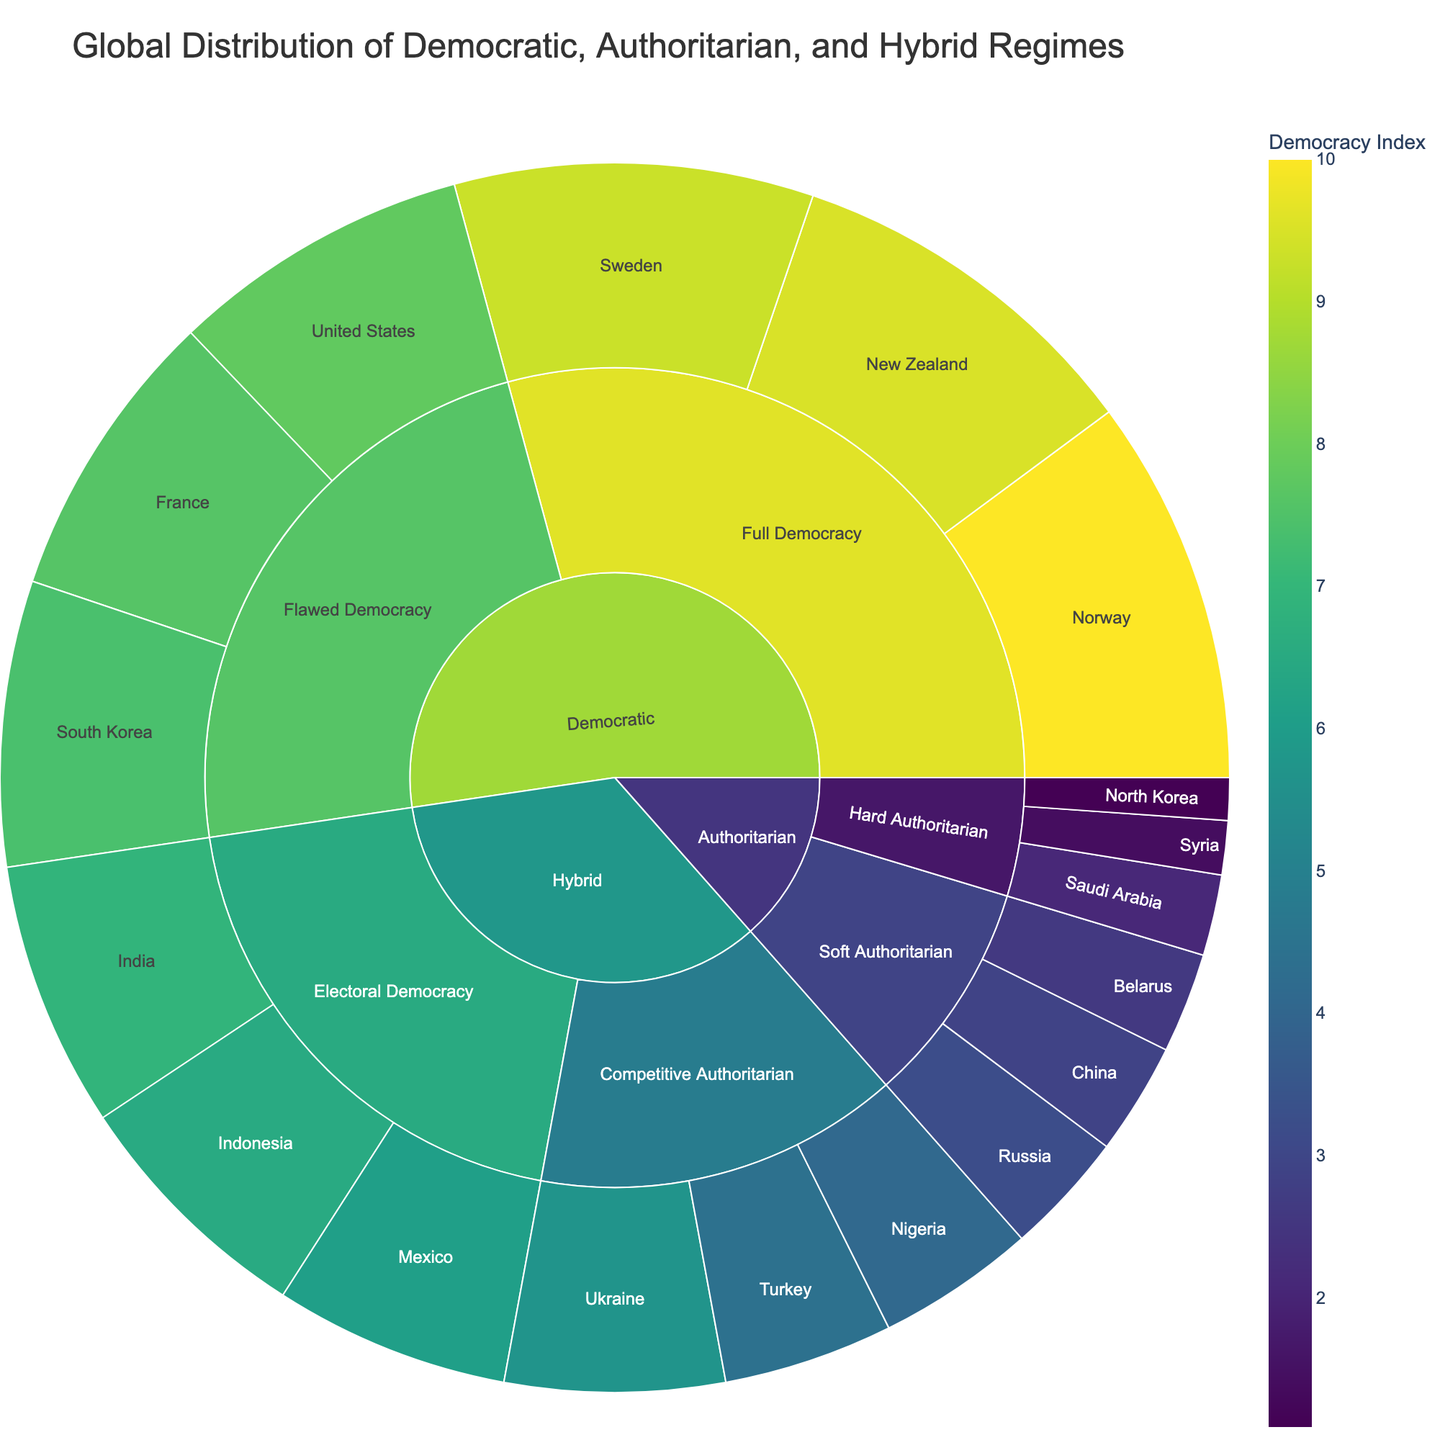What's the title of the figure? The title is usually located at the top of the figure. By observing this area, the title reads 'Global Distribution of Democratic, Authoritarian, and Hybrid Regimes'.
Answer: Global Distribution of Democratic, Authoritarian, and Hybrid Regimes Which category has the highest Democracy Index value? By following the color gradient from dark to light in the sunburst plot, the highest Democracy Index value is in the 'Democratic' category. Zooming into this category, the lightest segment belongs to 'Full Democracy', and within that, 'Norway' has the value of 10.
Answer: Democratic How many countries fall under the 'Hybrid' category? Examine the sector labeled 'Hybrid' and count the number of subdivisions connecting to it. There are two subcategories under 'Hybrid': 'Competitive Authoritarian' and 'Electoral Democracy'. Each subcategory has three countries, totaling six countries.
Answer: 6 What is the average Democracy Index value for 'Flawed Democracy'? Locate the 'Flawed Democracy' subcategory under 'Democratic'. Identify the values: United States (7.8), France (7.6), and South Korea (7.4). Calculate the average: (7.8 + 7.6 + 7.4) / 3 = 7.6.
Answer: 7.6 Compare the Democracy Index values of New Zealand and Saudi Arabia. Which is higher? Locate New Zealand under 'Full Democracy' in 'Democratic' with a value of 9.5 and Saudi Arabia under 'Hard Authoritarian' in 'Authoritarian' with a value of 2.1. Comparing these, New Zealand has the higher index.
Answer: New Zealand Which subcategory under the 'Authoritarian' category has a country with the lowest value? Under 'Authoritarian', look for the smallest sector by the color gradient. 'Hard Authoritarian' contains the darkest segment which represents 'North Korea' with a value of 1.1.
Answer: Hard Authoritarian What is the total sum of Democracy Index values in the 'Competitive Authoritarian' subcategory? Locate 'Competitive Authoritarian' in 'Hybrid'. Collect the values: Turkey (4.4), Ukraine (5.7), Nigeria (4.1). Sum these values: 4.4 + 5.7 + 4.1 = 14.2.
Answer: 14.2 What's the difference in Democracy Index values between Norway and North Korea? Norway in 'Full Democracy' has a value of 10, and North Korea in 'Hard Authoritarian' has a value of 1.1. The difference is calculated as 10 - 1.1 = 8.9.
Answer: 8.9 Identify the subcategory with countries having an average Democracy Index of more than 6 under the 'Hybrid' category. Consider both subcategories under 'Hybrid': 'Competitive Authoritarian' (values: 4.4, 5.7, 4.1) and 'Electoral Democracy' (values: 6.1, 6.5, 6.9). Only 'Electoral Democracy' has an average (6.5) above 6.
Answer: Electoral Democracy 